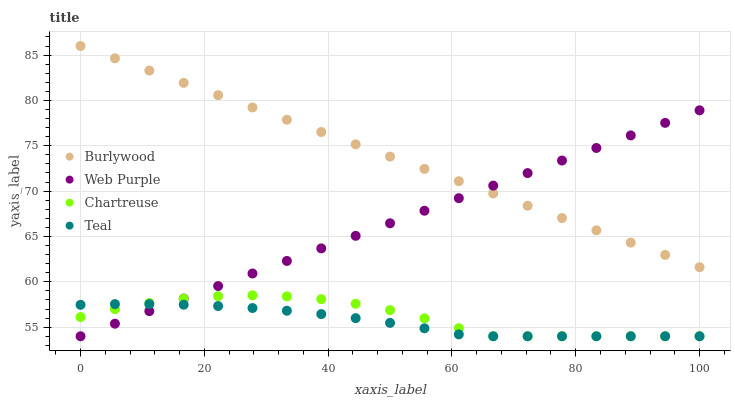Does Teal have the minimum area under the curve?
Answer yes or no. Yes. Does Burlywood have the maximum area under the curve?
Answer yes or no. Yes. Does Web Purple have the minimum area under the curve?
Answer yes or no. No. Does Web Purple have the maximum area under the curve?
Answer yes or no. No. Is Web Purple the smoothest?
Answer yes or no. Yes. Is Chartreuse the roughest?
Answer yes or no. Yes. Is Chartreuse the smoothest?
Answer yes or no. No. Is Web Purple the roughest?
Answer yes or no. No. Does Web Purple have the lowest value?
Answer yes or no. Yes. Does Burlywood have the highest value?
Answer yes or no. Yes. Does Web Purple have the highest value?
Answer yes or no. No. Is Teal less than Burlywood?
Answer yes or no. Yes. Is Burlywood greater than Teal?
Answer yes or no. Yes. Does Burlywood intersect Web Purple?
Answer yes or no. Yes. Is Burlywood less than Web Purple?
Answer yes or no. No. Is Burlywood greater than Web Purple?
Answer yes or no. No. Does Teal intersect Burlywood?
Answer yes or no. No. 